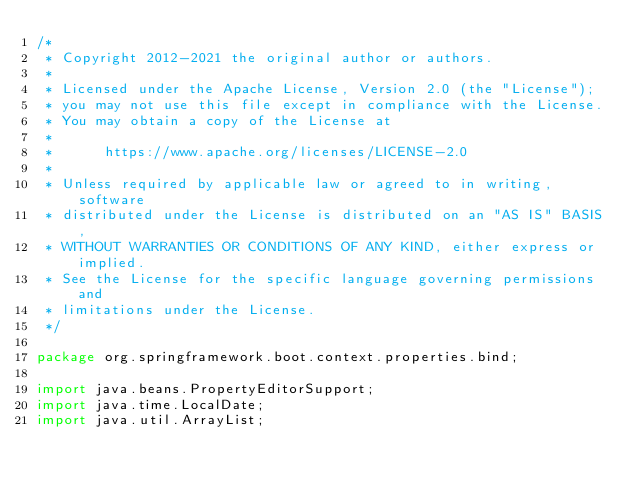<code> <loc_0><loc_0><loc_500><loc_500><_Java_>/*
 * Copyright 2012-2021 the original author or authors.
 *
 * Licensed under the Apache License, Version 2.0 (the "License");
 * you may not use this file except in compliance with the License.
 * You may obtain a copy of the License at
 *
 *      https://www.apache.org/licenses/LICENSE-2.0
 *
 * Unless required by applicable law or agreed to in writing, software
 * distributed under the License is distributed on an "AS IS" BASIS,
 * WITHOUT WARRANTIES OR CONDITIONS OF ANY KIND, either express or implied.
 * See the License for the specific language governing permissions and
 * limitations under the License.
 */

package org.springframework.boot.context.properties.bind;

import java.beans.PropertyEditorSupport;
import java.time.LocalDate;
import java.util.ArrayList;</code> 